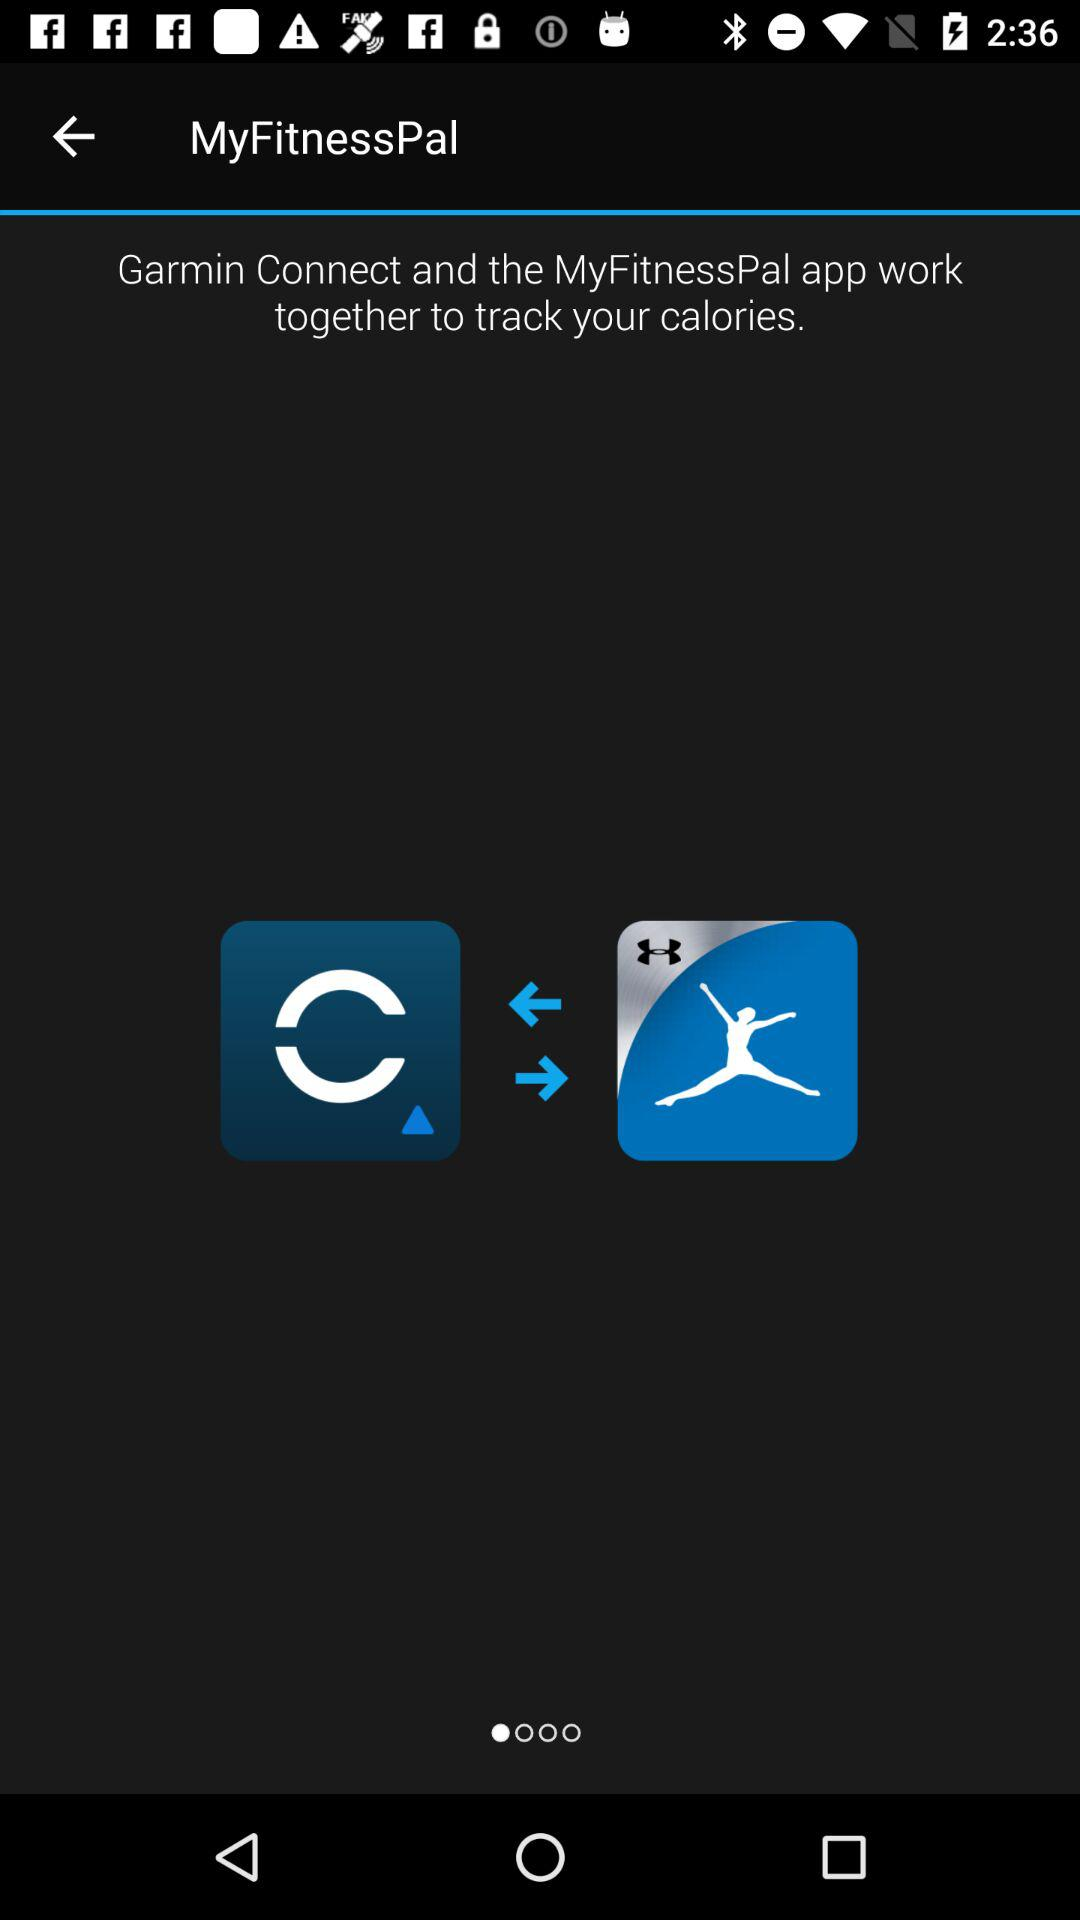What is the name of the application? The name of the application is "MyFitnessPal". 